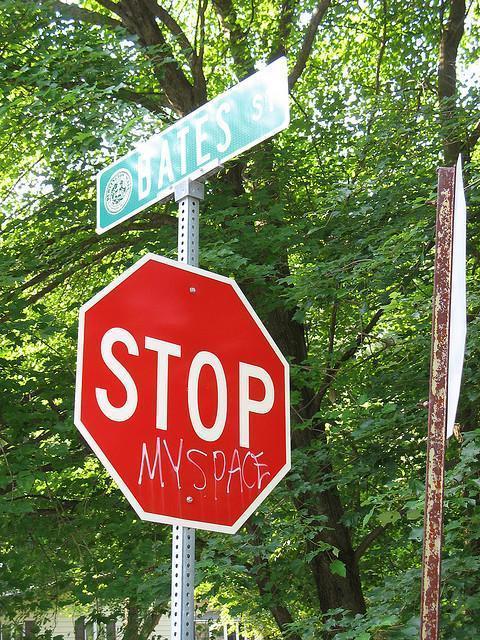How many sheep walking in a line in this picture?
Give a very brief answer. 0. 